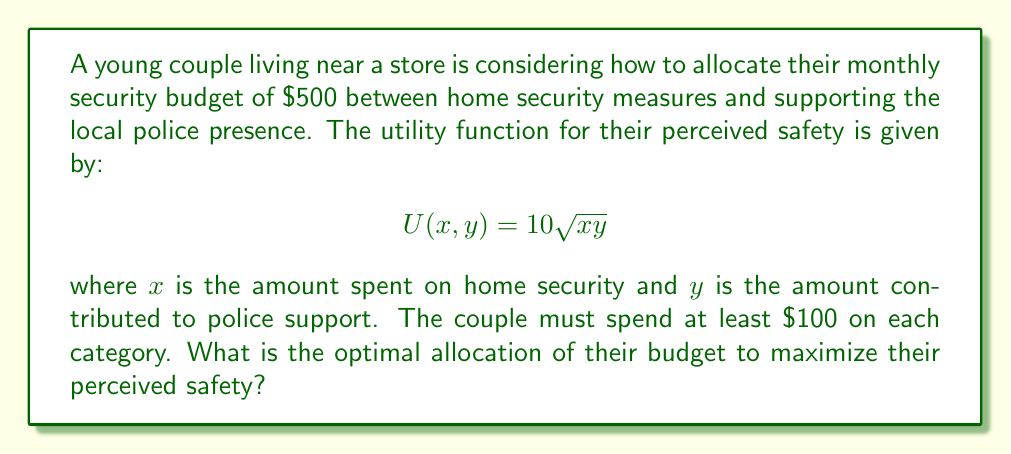Solve this math problem. To solve this problem, we'll use the method of Lagrange multipliers:

1) First, we set up the Lagrangian function:
   $$L(x, y, \lambda) = 10\sqrt{xy} + \lambda(500 - x - y)$$

2) We then take partial derivatives and set them equal to zero:
   $$\frac{\partial L}{\partial x} = \frac{5y}{\sqrt{xy}} - \lambda = 0$$
   $$\frac{\partial L}{\partial y} = \frac{5x}{\sqrt{xy}} - \lambda = 0$$
   $$\frac{\partial L}{\partial \lambda} = 500 - x - y = 0$$

3) From the first two equations, we can see that:
   $$\frac{5y}{\sqrt{xy}} = \frac{5x}{\sqrt{xy}}$$
   This implies that $x = y$.

4) Substituting this into the budget constraint:
   $$500 - x - y = 0$$
   $$500 - 2x = 0$$
   $$x = y = 250$$

5) We need to check if this solution satisfies the constraint of spending at least $100 on each category. Since $250 > 100$, this constraint is satisfied.

6) To confirm this is a maximum, we can check the second derivatives:
   $$\frac{\partial^2 U}{\partial x^2} = -\frac{5y}{2(xy)^{3/2}} < 0$$
   $$\frac{\partial^2 U}{\partial y^2} = -\frac{5x}{2(xy)^{3/2}} < 0$$
   These are both negative, confirming a maximum.
Answer: The optimal allocation is to spend $250 on home security and $250 on police support. 